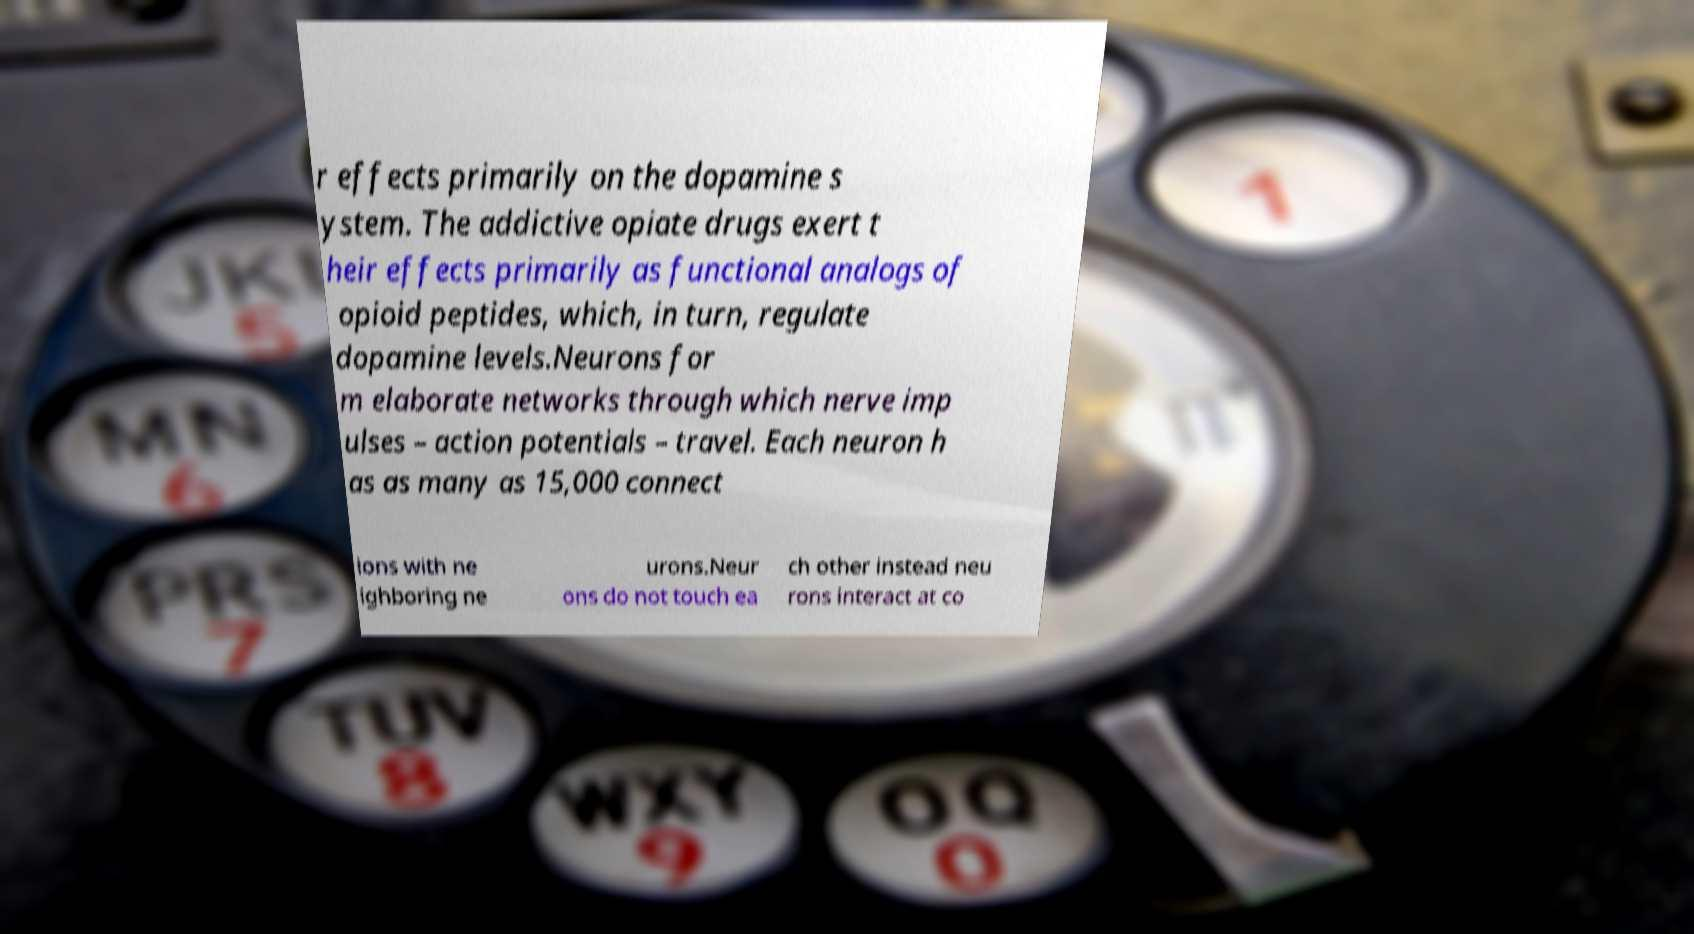For documentation purposes, I need the text within this image transcribed. Could you provide that? r effects primarily on the dopamine s ystem. The addictive opiate drugs exert t heir effects primarily as functional analogs of opioid peptides, which, in turn, regulate dopamine levels.Neurons for m elaborate networks through which nerve imp ulses – action potentials – travel. Each neuron h as as many as 15,000 connect ions with ne ighboring ne urons.Neur ons do not touch ea ch other instead neu rons interact at co 